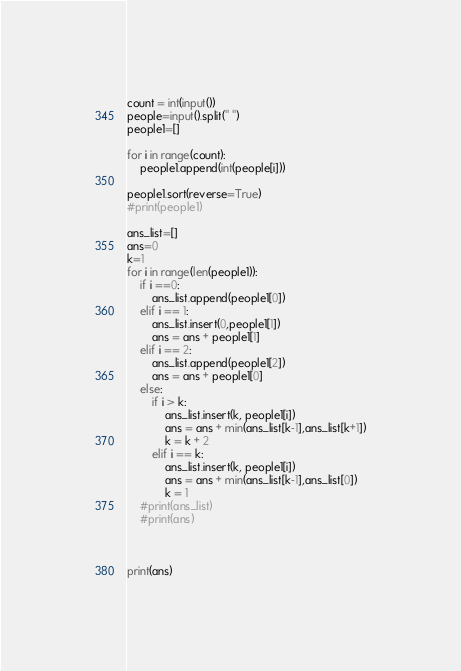<code> <loc_0><loc_0><loc_500><loc_500><_Python_>count = int(input())
people=input().split(" ")
people1=[]

for i in range(count):
    people1.append(int(people[i]))

people1.sort(reverse=True)
#print(people1)

ans_list=[]
ans=0
k=1
for i in range(len(people1)):
    if i ==0:
        ans_list.append(people1[0])
    elif i == 1:
        ans_list.insert(0,people1[1])
        ans = ans + people1[1]
    elif i == 2:
        ans_list.append(people1[2])
        ans = ans + people1[0]
    else:
        if i > k:
            ans_list.insert(k, people1[i])
            ans = ans + min(ans_list[k-1],ans_list[k+1])
            k = k + 2
        elif i == k:
            ans_list.insert(k, people1[i])
            ans = ans + min(ans_list[k-1],ans_list[0])
            k = 1
    #print(ans_list)
    #print(ans)


    
print(ans)


</code> 